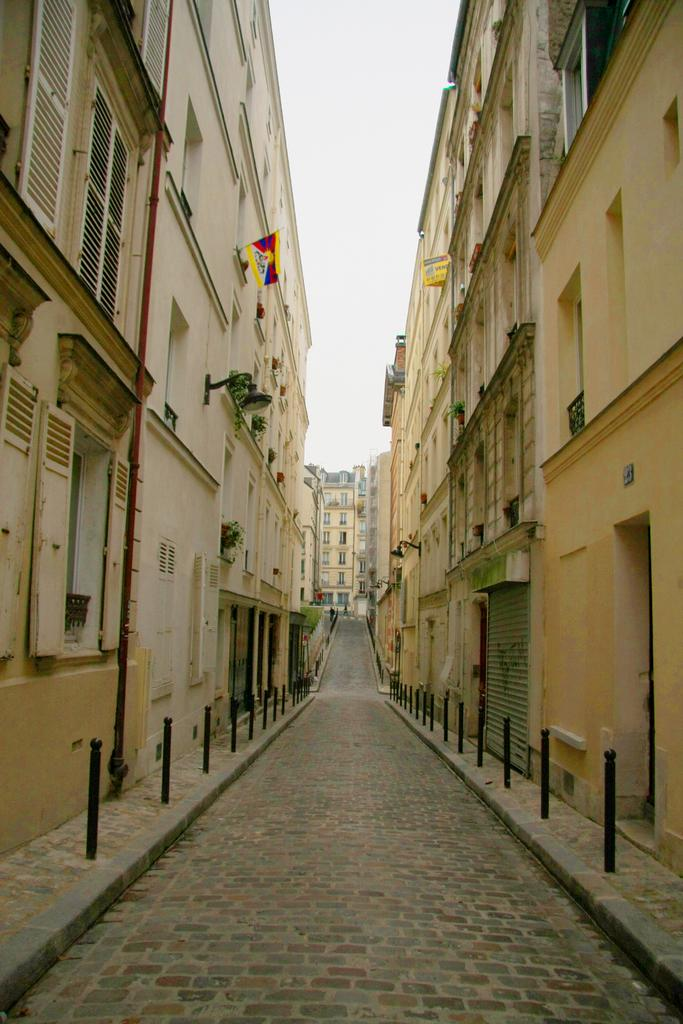What is the main feature in the middle of the image? There is a path in the middle of the image. What can be seen on either side of the path? There are buildings on either side of the path. What is visible in the background of the image? The sky is visible in the background of the image. Can you see any parcels being delivered along the path in the image? There is no indication of parcels or delivery in the image; it only shows a path with buildings on either side and the sky in the background. 